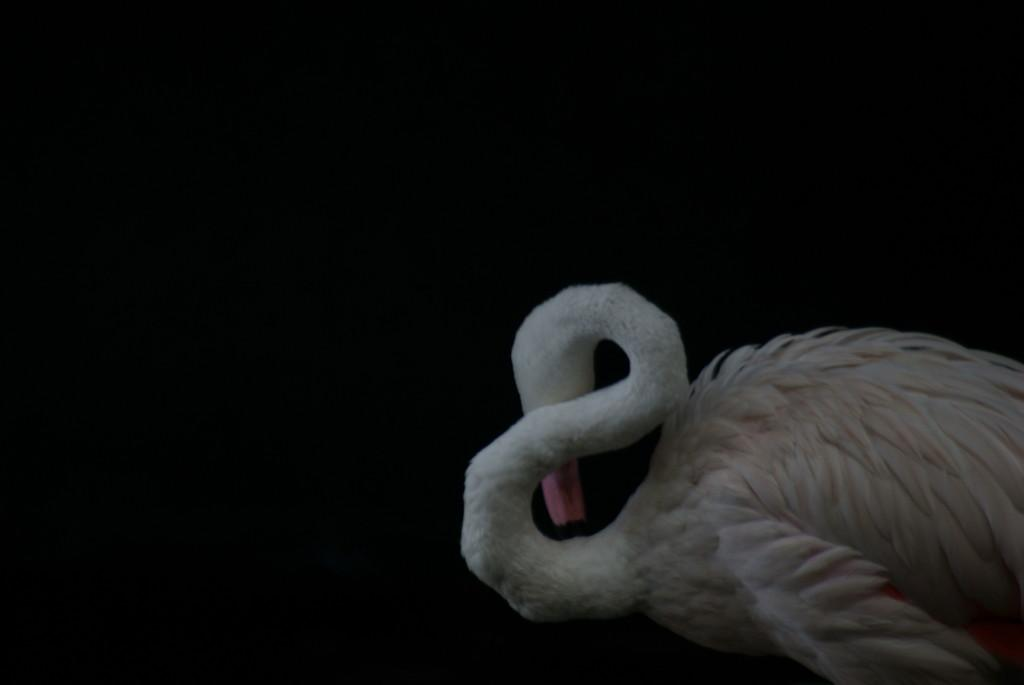What animal is the main subject of the image? There is a swan in the image. Can you describe the background of the image? The background of the image is dark. What type of wine is being served at the border in the image? There is no wine or border present in the image; it features a swan with a dark background. Can you tell me how many robins are visible in the image? There are no robins present in the image; it features a swan. 